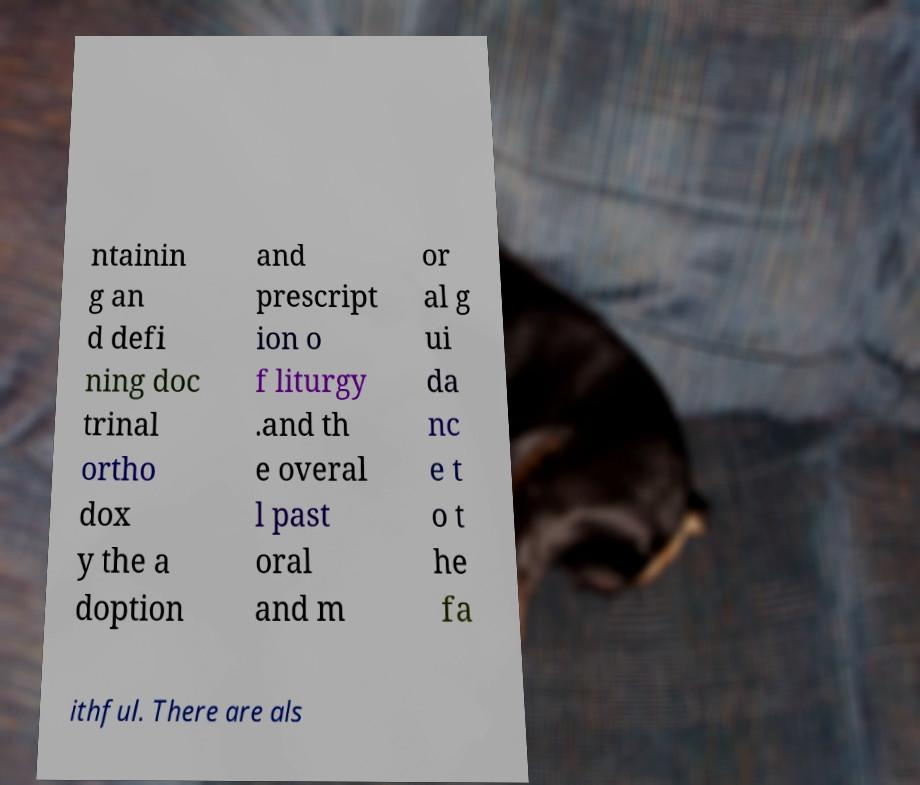Can you read and provide the text displayed in the image?This photo seems to have some interesting text. Can you extract and type it out for me? ntainin g an d defi ning doc trinal ortho dox y the a doption and prescript ion o f liturgy .and th e overal l past oral and m or al g ui da nc e t o t he fa ithful. There are als 